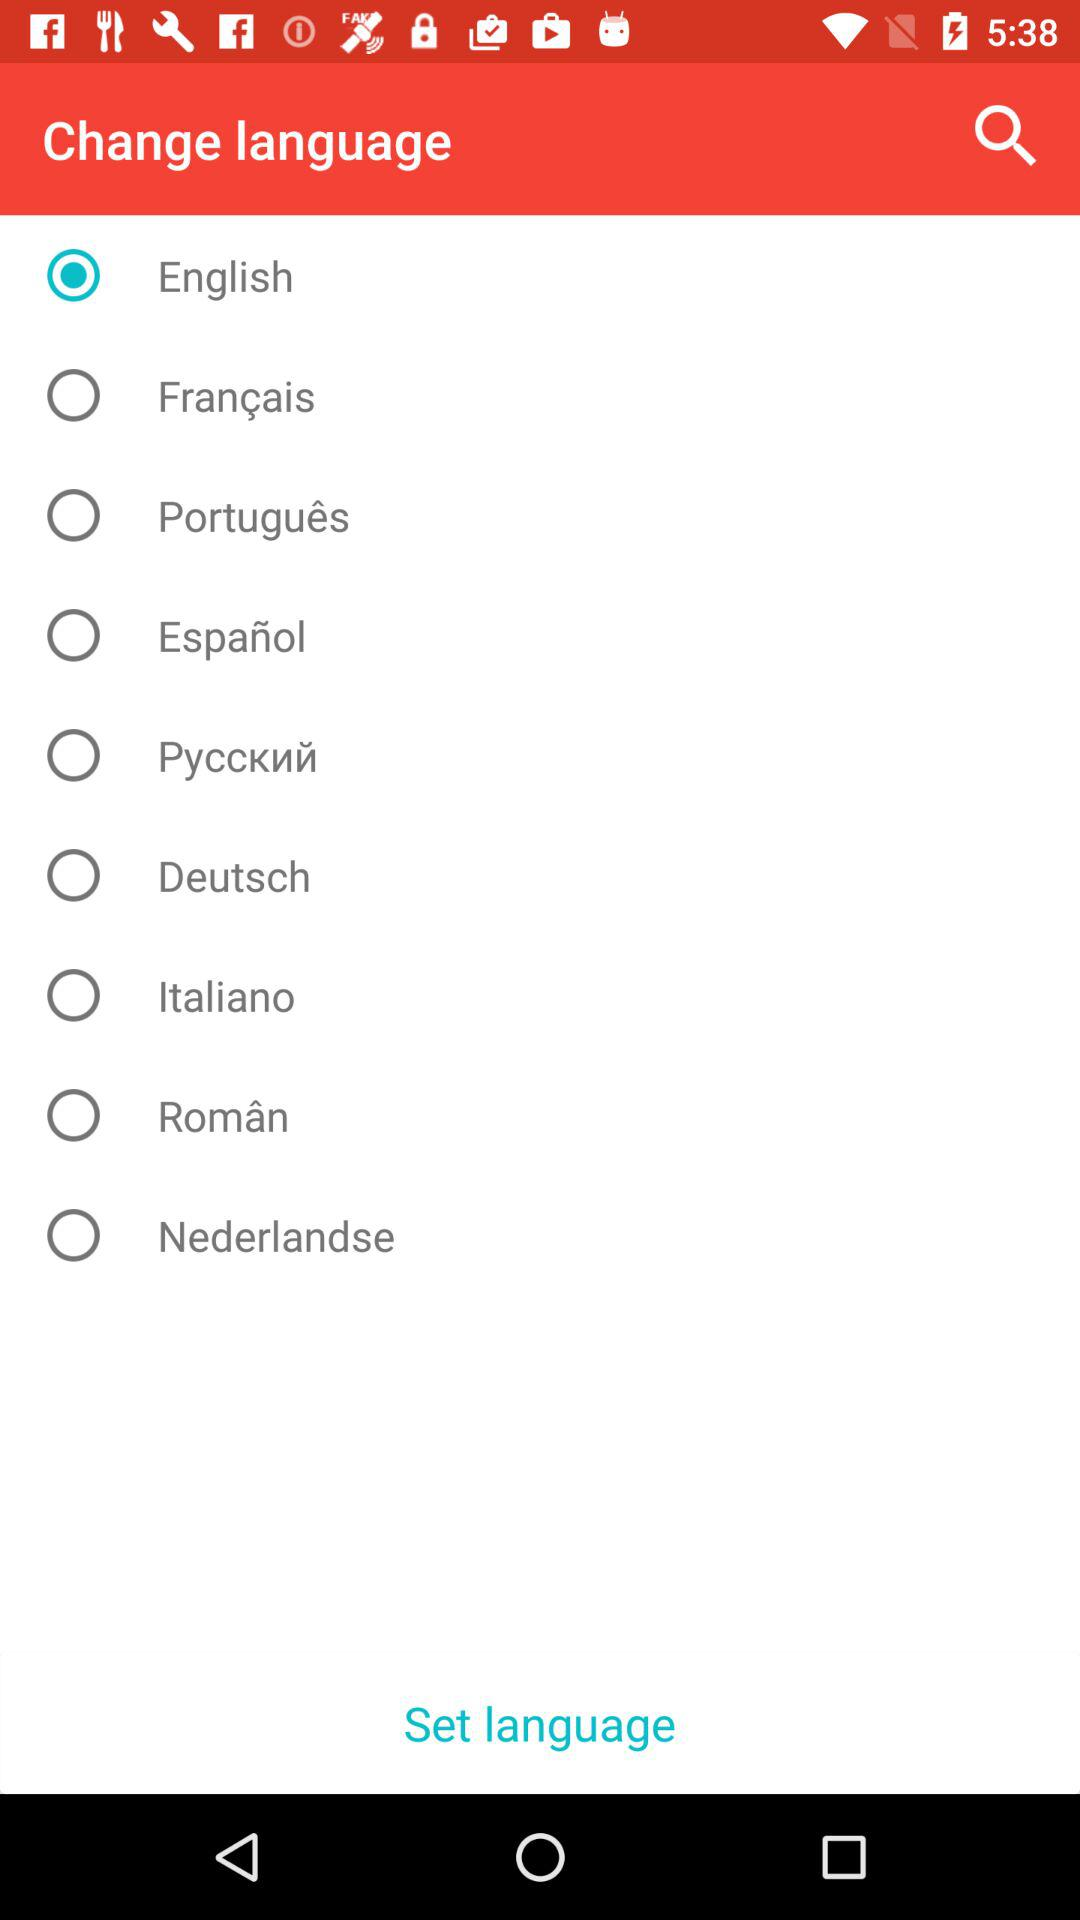Which language is selected? The selected language is English. 